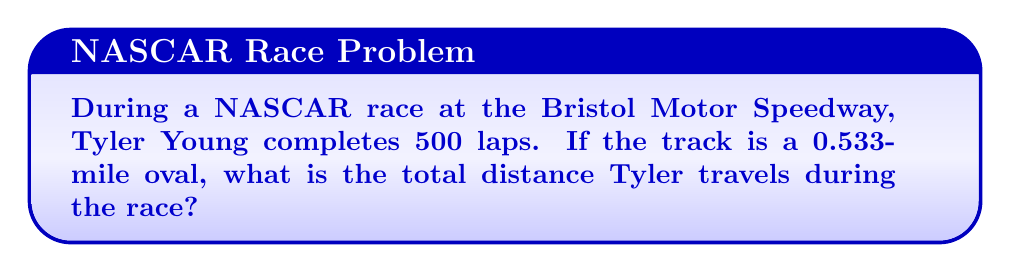What is the answer to this math problem? To solve this problem, we need to follow these steps:

1. Identify the given information:
   - Number of laps: 500
   - Length of one lap: 0.533 miles

2. Set up the equation to calculate the total distance:
   $$ \text{Total Distance} = \text{Number of Laps} \times \text{Length of One Lap} $$

3. Substitute the values into the equation:
   $$ \text{Total Distance} = 500 \times 0.533 \text{ miles} $$

4. Perform the multiplication:
   $$ \text{Total Distance} = 266.5 \text{ miles} $$

Therefore, Tyler Young travels a total distance of 266.5 miles during the 500-lap race at Bristol Motor Speedway.
Answer: 266.5 miles 